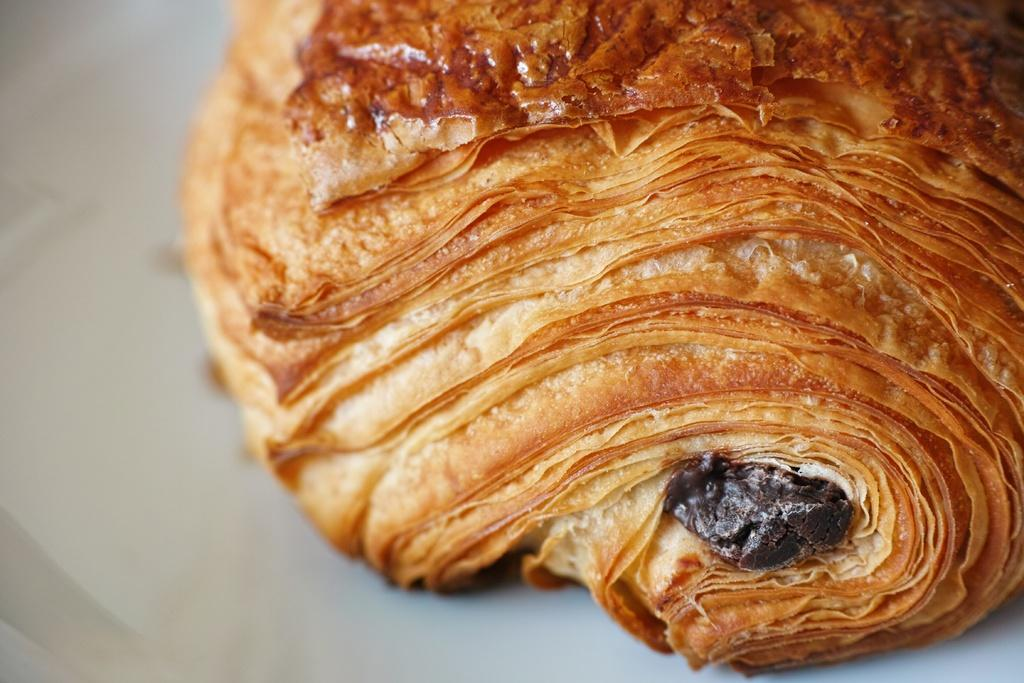What color is the food in the image? The food in the image is brown-colored. What color can be seen in the background of the image? There is white color visible in the background of the image. How many mice are sitting on the food in the image? There are no mice present in the image. What distance is required to join the two white areas in the background? There is only one white area visible in the background, so it is not possible to join two white areas. 